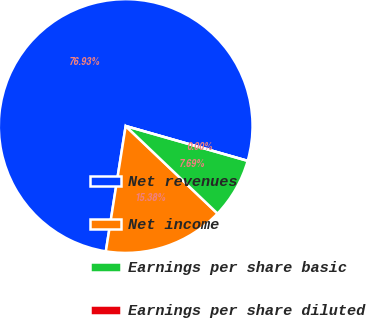<chart> <loc_0><loc_0><loc_500><loc_500><pie_chart><fcel>Net revenues<fcel>Net income<fcel>Earnings per share basic<fcel>Earnings per share diluted<nl><fcel>76.92%<fcel>15.38%<fcel>7.69%<fcel>0.0%<nl></chart> 